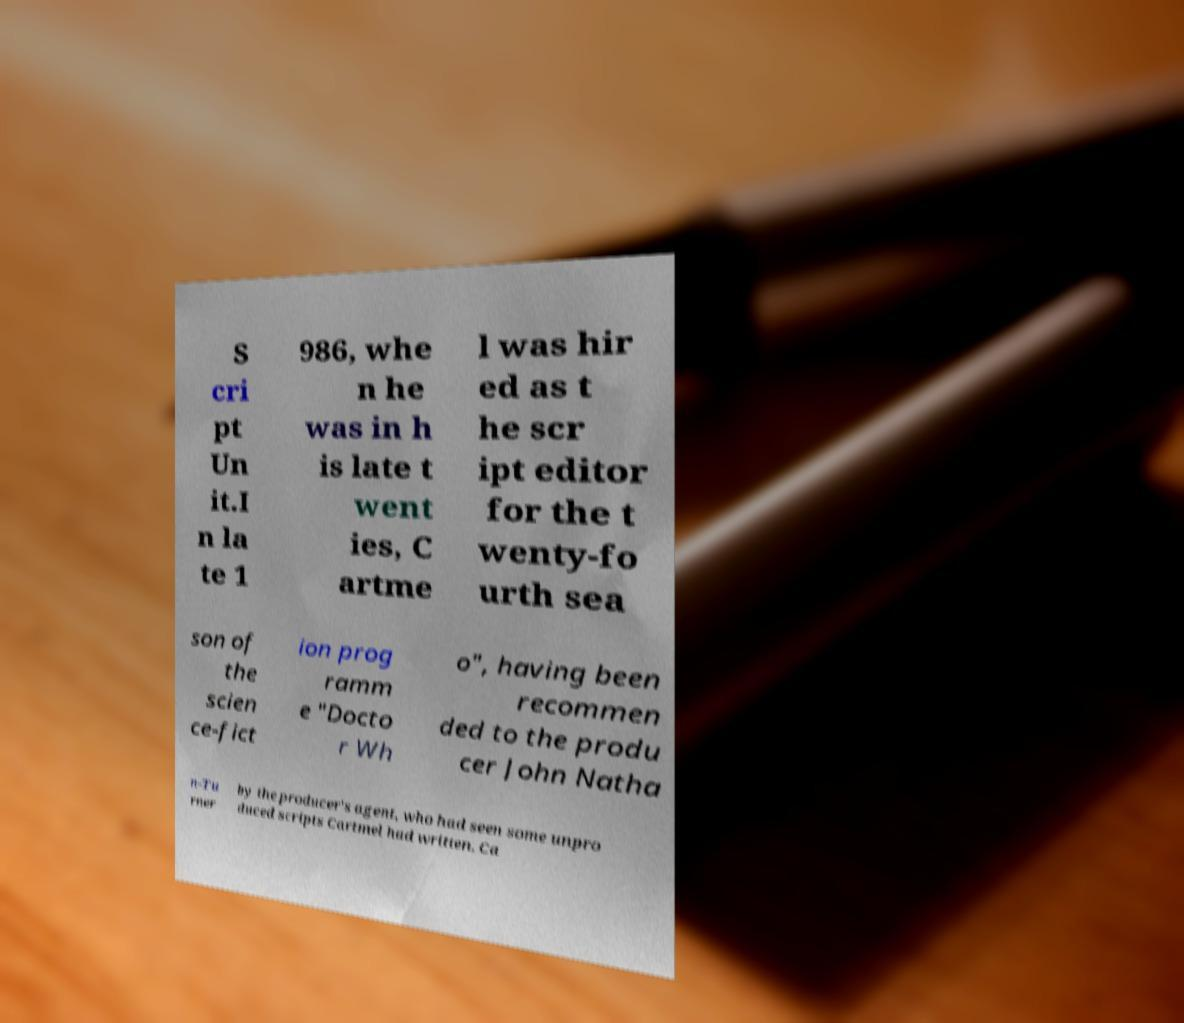Can you read and provide the text displayed in the image?This photo seems to have some interesting text. Can you extract and type it out for me? S cri pt Un it.I n la te 1 986, whe n he was in h is late t went ies, C artme l was hir ed as t he scr ipt editor for the t wenty-fo urth sea son of the scien ce-fict ion prog ramm e "Docto r Wh o", having been recommen ded to the produ cer John Natha n-Tu rner by the producer's agent, who had seen some unpro duced scripts Cartmel had written. Ca 